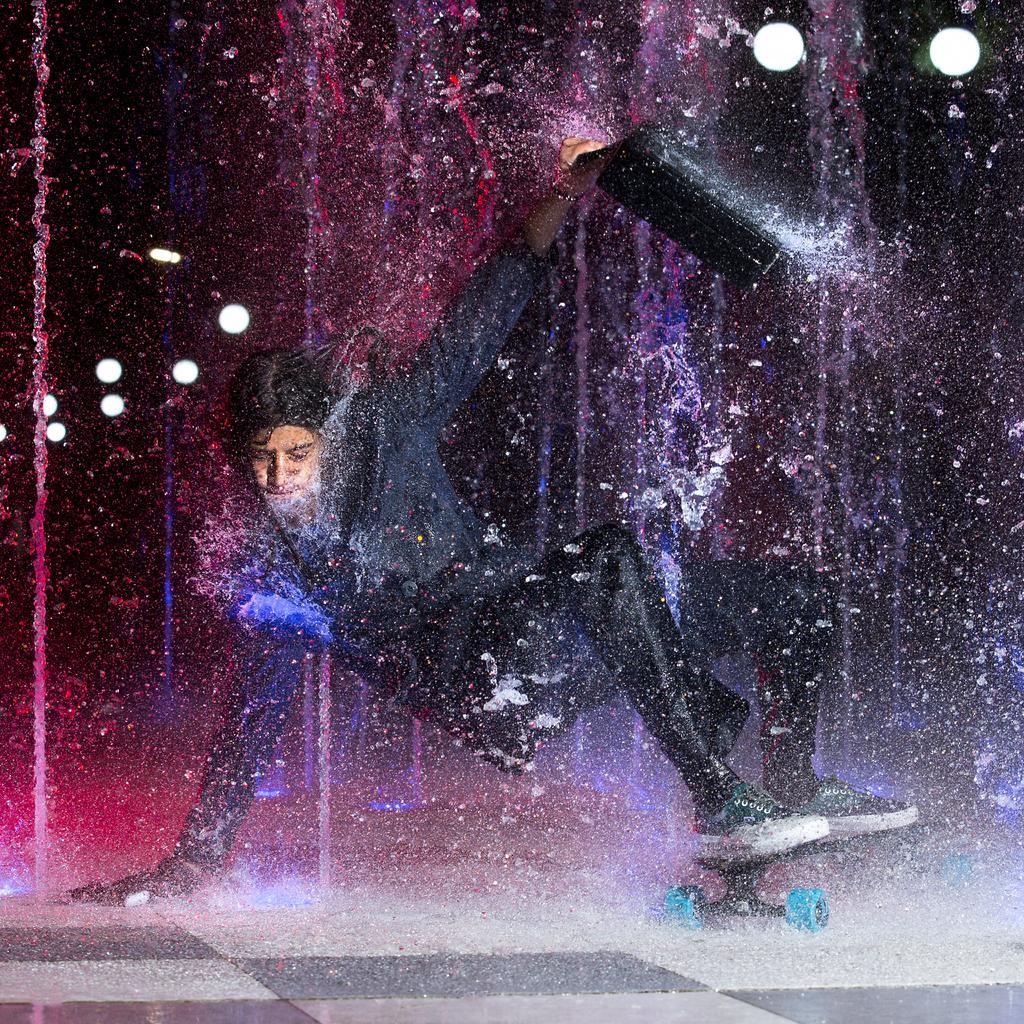Describe this image in one or two sentences. In this image person is performing the somersault on the dance floor. At the back side there are lights. 